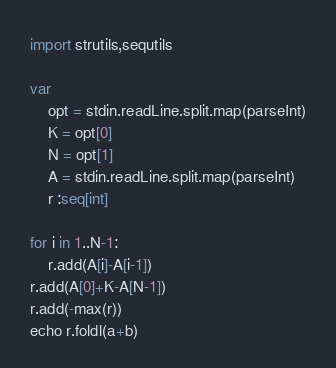Convert code to text. <code><loc_0><loc_0><loc_500><loc_500><_Nim_>import strutils,sequtils

var
    opt = stdin.readLine.split.map(parseInt)
    K = opt[0]
    N = opt[1]
    A = stdin.readLine.split.map(parseInt)
    r :seq[int]

for i in 1..N-1:
    r.add(A[i]-A[i-1])
r.add(A[0]+K-A[N-1])
r.add(-max(r))
echo r.foldl(a+b)</code> 